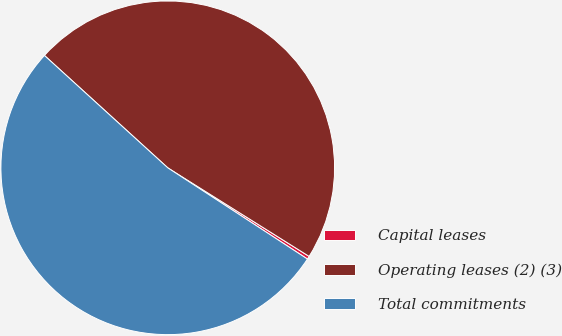Convert chart. <chart><loc_0><loc_0><loc_500><loc_500><pie_chart><fcel>Capital leases<fcel>Operating leases (2) (3)<fcel>Total commitments<nl><fcel>0.3%<fcel>47.15%<fcel>52.55%<nl></chart> 